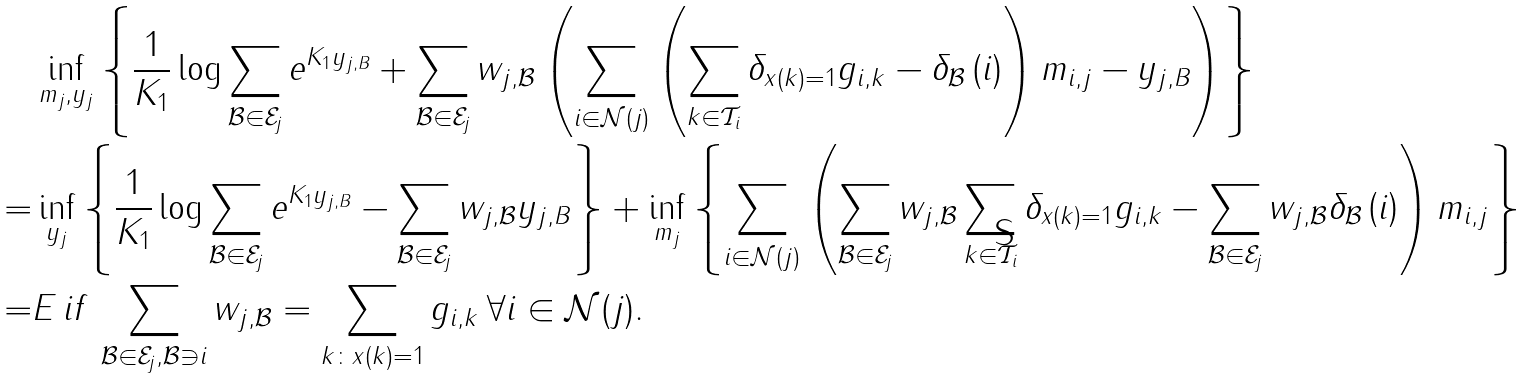<formula> <loc_0><loc_0><loc_500><loc_500>& \inf _ { m _ { j } , y _ { j } } \left \{ \frac { 1 } { K _ { 1 } } \log \sum _ { \mathcal { B } \in \mathcal { E } _ { j } } e ^ { K _ { 1 } y _ { j , B } } + \sum _ { \mathcal { B } \in \mathcal { E } _ { j } } w _ { j , \mathcal { B } } \left ( \sum _ { i \in \mathcal { N } ( j ) } \left ( \sum _ { k \in \mathcal { T } _ { i } } \delta _ { x ( k ) = 1 } g _ { i , k } - \delta _ { \mathcal { B } } \left ( i \right ) \right ) m _ { i , j } - y _ { j , B } \right ) \right \} \\ = & \inf _ { y _ { j } } \left \{ \frac { 1 } { K _ { 1 } } \log \sum _ { \mathcal { B } \in \mathcal { E } _ { j } } e ^ { K _ { 1 } y _ { j , B } } - \sum _ { \mathcal { B } \in \mathcal { E } _ { j } } w _ { j , \mathcal { B } } y _ { j , B } \right \} + \inf _ { m _ { j } } \left \{ \sum _ { i \in \mathcal { N } ( j ) } \left ( \sum _ { \mathcal { B } \in \mathcal { E } _ { j } } w _ { j , \mathcal { B } } \sum _ { k \in \mathcal { T } _ { i } } \delta _ { x ( k ) = 1 } g _ { i , k } - \sum _ { \mathcal { B } \in \mathcal { E } _ { j } } w _ { j , \mathcal { B } } \delta _ { \mathcal { B } } \left ( i \right ) \right ) m _ { i , j } \right \} \\ = & E \, i f \, \sum _ { \mathcal { B } \in \mathcal { E } _ { j } , \mathcal { B } \ni i } w _ { j , \mathcal { B } } = \sum _ { k \colon x ( k ) = 1 } g _ { i , k } \, \forall i \in \mathcal { N } ( j ) .</formula> 